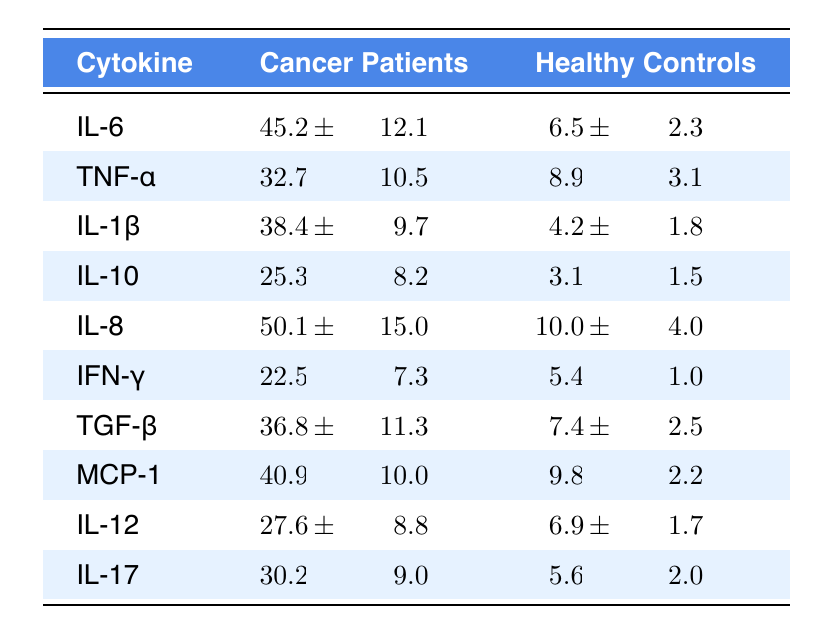What is the mean release level of IL-6 in cancer patients? The table shows that the mean release level of IL-6 for cancer patients is listed as 45.2.
Answer: 45.2 What is the standard deviation of TNF-α for healthy controls? According to the table, the standard deviation of TNF-α for healthy controls is 3.1.
Answer: 3.1 Which cytokine has the highest mean release level in cancer patients? The highest mean release level in cancer patients is IL-8 at 50.1, as seen in the table.
Answer: IL-8 How much higher is the mean IL-10 release level in cancer patients compared to healthy controls? The mean IL-10 release level in cancer patients is 25.3, and in healthy controls, it is 3.1. The difference is 25.3 - 3.1 = 22.2.
Answer: 22.2 Is the mean release level of IL-1β higher in cancer patients than in healthy controls? The mean for IL-1β in cancer patients is 38.4, while for healthy controls it is 4.2. Since 38.4 is greater than 4.2, the statement is true.
Answer: Yes What is the combined mean release level of IL-6 and IL-8 in cancer patients? The mean release level of IL-6 is 45.2 and IL-8 is 50.1. Therefore, the combined mean is 45.2 + 50.1 = 95.3.
Answer: 95.3 Which cytokine shows the lowest mean release level in healthy controls? Looking at the table, the cytokine with the lowest mean release level in healthy controls is IL-1β at 4.2.
Answer: IL-1β What is the mean difference of MCP-1 between cancer patients and healthy controls? The mean release level for MCP-1 in cancer patients is 40.9, and in healthy controls, it is 9.8. The mean difference is 40.9 - 9.8 = 31.1.
Answer: 31.1 Is the standard deviation of IFN-γ in cancer patients greater than that of healthy controls? The standard deviation for IFN-γ in cancer patients is 7.3 while in healthy controls it is 1.0. Since 7.3 is greater than 1.0, the statement is true.
Answer: Yes What is the average standard deviation of all cytokines in cancer patients? The standard deviations for cancer patients are 12.1, 10.5, 9.7, 8.2, 15.0, 7.3, 11.3, 10.0, 8.8, and 9.0. Summing these gives 12.1 + 10.5 + 9.7 + 8.2 + 15.0 + 7.3 + 11.3 + 10.0 + 8.8 + 9.0 =  82.9. Dividing by 10 gives an average of 8.29.
Answer: 8.29 